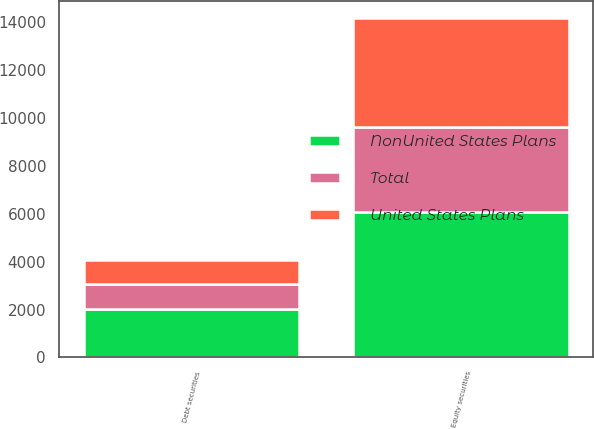<chart> <loc_0><loc_0><loc_500><loc_500><stacked_bar_chart><ecel><fcel>Equity securities<fcel>Debt securities<nl><fcel>NonUnited States Plans<fcel>6080<fcel>2030<nl><fcel>Total<fcel>3550<fcel>1020<nl><fcel>United States Plans<fcel>4565<fcel>1030<nl></chart> 